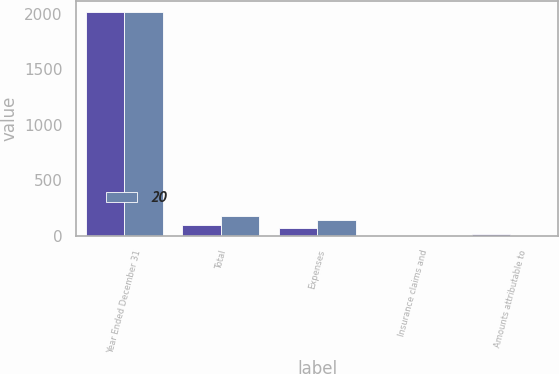<chart> <loc_0><loc_0><loc_500><loc_500><stacked_bar_chart><ecel><fcel>Year Ended December 31<fcel>Total<fcel>Expenses<fcel>Insurance claims and<fcel>Amounts attributable to<nl><fcel>nan<fcel>2014<fcel>97<fcel>75<fcel>2<fcel>20<nl><fcel>20<fcel>2013<fcel>181<fcel>141<fcel>3<fcel>2<nl></chart> 